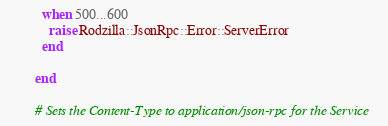Convert code to text. <code><loc_0><loc_0><loc_500><loc_500><_Ruby_>          when 500...600
            raise Rodzilla::JsonRpc::Error::ServerError
          end

        end

        # Sets the Content-Type to application/json-rpc for the Service</code> 